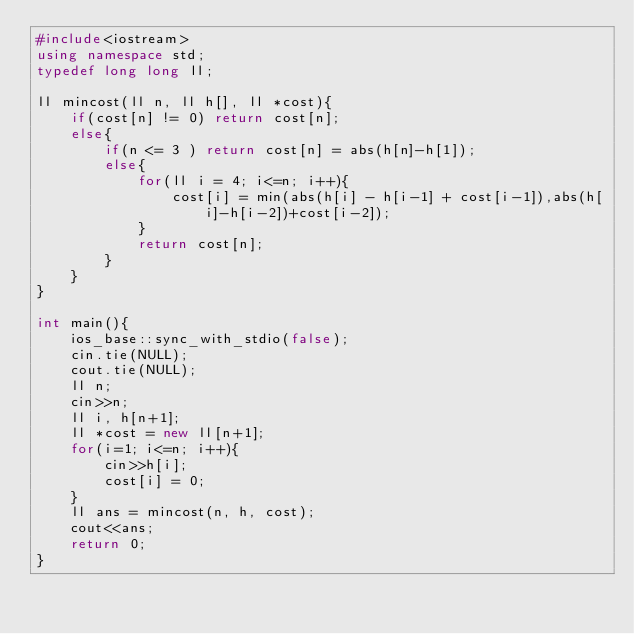Convert code to text. <code><loc_0><loc_0><loc_500><loc_500><_C++_>#include<iostream>
using namespace std;
typedef long long ll;

ll mincost(ll n, ll h[], ll *cost){
    if(cost[n] != 0) return cost[n];
    else{
    	if(n <= 3 ) return cost[n] = abs(h[n]-h[1]);
        else{
            for(ll i = 4; i<=n; i++){
                cost[i] = min(abs(h[i] - h[i-1] + cost[i-1]),abs(h[i]-h[i-2])+cost[i-2]);
            }
            return cost[n];
        }
    }
}

int main(){
    ios_base::sync_with_stdio(false);
    cin.tie(NULL);
    cout.tie(NULL);
	ll n;
	cin>>n;
  	ll i, h[n+1];
    ll *cost = new ll[n+1];
	for(i=1; i<=n; i++){
        cin>>h[i];
        cost[i] = 0;
    }
  	ll ans = mincost(n, h, cost);
  	cout<<ans;
	return 0;
}
</code> 